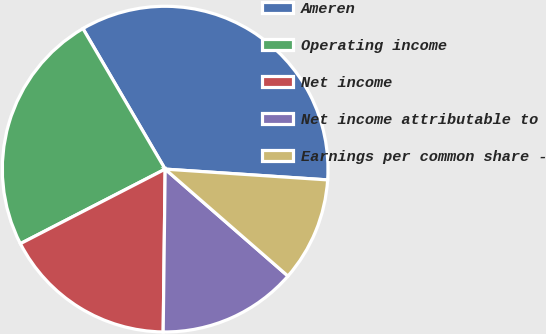<chart> <loc_0><loc_0><loc_500><loc_500><pie_chart><fcel>Ameren<fcel>Operating income<fcel>Net income<fcel>Net income attributable to<fcel>Earnings per common share -<nl><fcel>34.48%<fcel>24.14%<fcel>17.24%<fcel>13.79%<fcel>10.35%<nl></chart> 